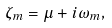Convert formula to latex. <formula><loc_0><loc_0><loc_500><loc_500>\zeta _ { m } = \mu + i \omega _ { m } ,</formula> 